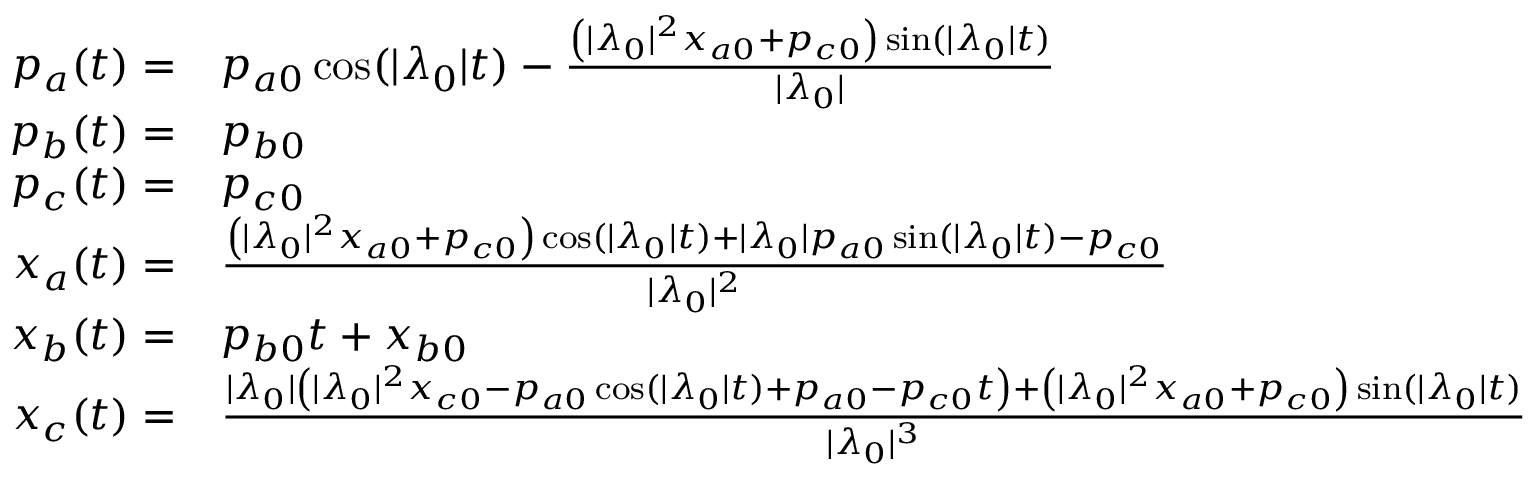Convert formula to latex. <formula><loc_0><loc_0><loc_500><loc_500>\begin{array} { r l } { p _ { a } ( t ) = } & { p _ { a 0 } \cos ( | \lambda _ { 0 } | t ) - \frac { \left ( | \lambda _ { 0 } | ^ { 2 } x _ { a 0 } + p _ { c 0 } \right ) \sin ( | \lambda _ { 0 } | t ) } { | \lambda _ { 0 } | } } \\ { p _ { b } ( t ) = } & { p _ { b 0 } } \\ { p _ { c } ( t ) = } & { p _ { c 0 } } \\ { x _ { a } ( t ) = } & { \frac { \left ( | \lambda _ { 0 } | ^ { 2 } x _ { a 0 } + p _ { c 0 } \right ) \cos ( | \lambda _ { 0 } | t ) + | \lambda _ { 0 } | p _ { a 0 } \sin ( | \lambda _ { 0 } | t ) - p _ { c 0 } } { | \lambda _ { 0 } | ^ { 2 } } } \\ { x _ { b } ( t ) = } & { p _ { b 0 } t + x _ { b 0 } } \\ { x _ { c } ( t ) = } & { \frac { | \lambda _ { 0 } | \left ( | \lambda _ { 0 } | ^ { 2 } x _ { c 0 } - p _ { a 0 } \cos ( | \lambda _ { 0 } | t ) + p _ { a 0 } - p _ { c 0 } t \right ) + \left ( | \lambda _ { 0 } | ^ { 2 } x _ { a 0 } + p _ { c 0 } \right ) \sin ( | \lambda _ { 0 } | t ) } { | \lambda _ { 0 } | ^ { 3 } } } \end{array}</formula> 